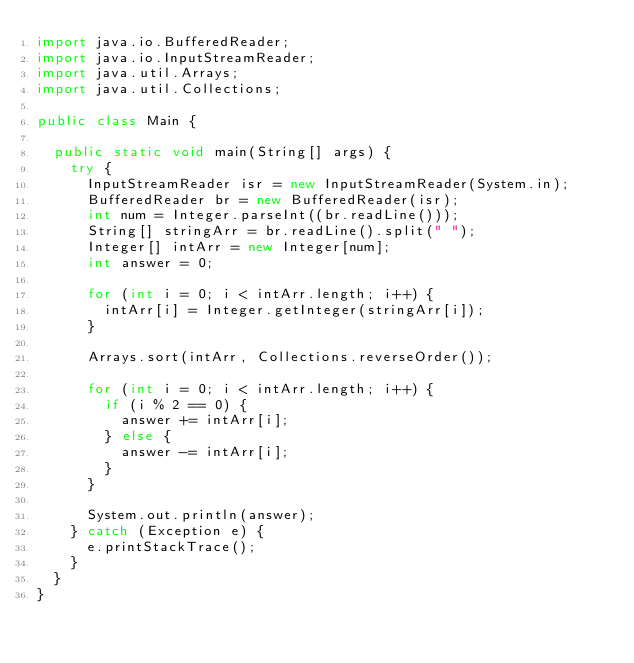Convert code to text. <code><loc_0><loc_0><loc_500><loc_500><_Java_>import java.io.BufferedReader;
import java.io.InputStreamReader;
import java.util.Arrays;
import java.util.Collections;

public class Main {

	public static void main(String[] args) {
		try {
			InputStreamReader isr = new InputStreamReader(System.in);
			BufferedReader br = new BufferedReader(isr);
			int num = Integer.parseInt((br.readLine()));
			String[] stringArr = br.readLine().split(" ");
			Integer[] intArr = new Integer[num];
			int answer = 0;

			for (int i = 0; i < intArr.length; i++) {
				intArr[i] = Integer.getInteger(stringArr[i]);
			}

			Arrays.sort(intArr, Collections.reverseOrder());

			for (int i = 0; i < intArr.length; i++) {
				if (i % 2 == 0) {
					answer += intArr[i];
				} else {
					answer -= intArr[i];
				}
			}

			System.out.println(answer);
		} catch (Exception e) {
			e.printStackTrace();
		}
	}
}
</code> 